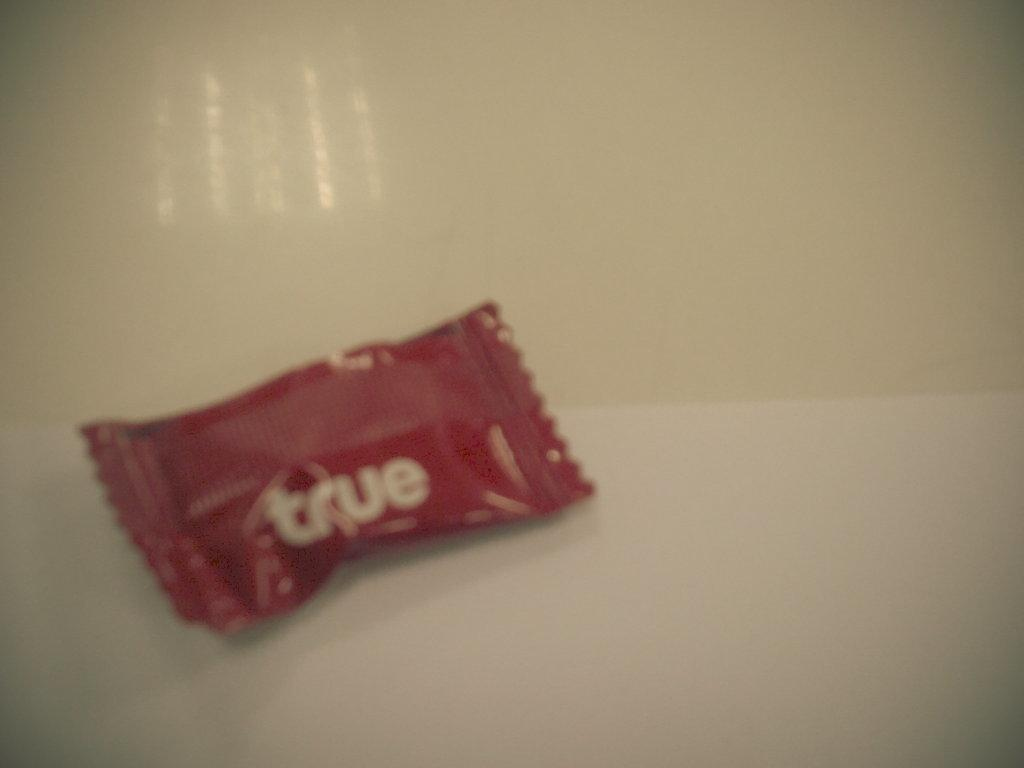What type of food item is present in the image? There is a chocolate in the image. What type of cover is protecting the chocolate in the image? There is no cover present in the image; the chocolate is visible without any protection. 